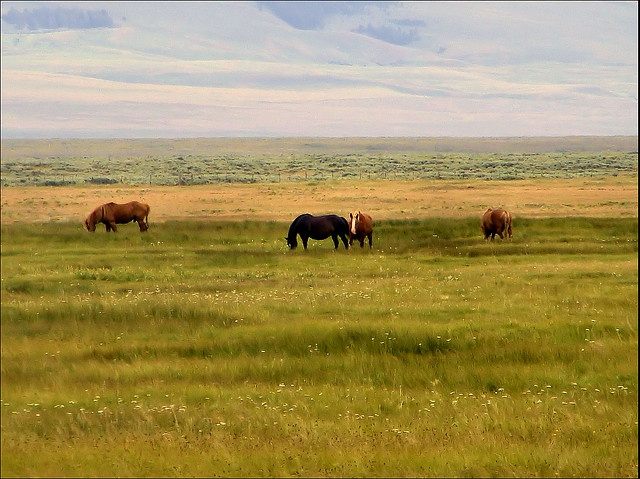Describe the objects in this image and their specific colors. I can see horse in black, olive, and maroon tones, horse in black, maroon, and brown tones, horse in black, maroon, and brown tones, and horse in black, maroon, and brown tones in this image. 